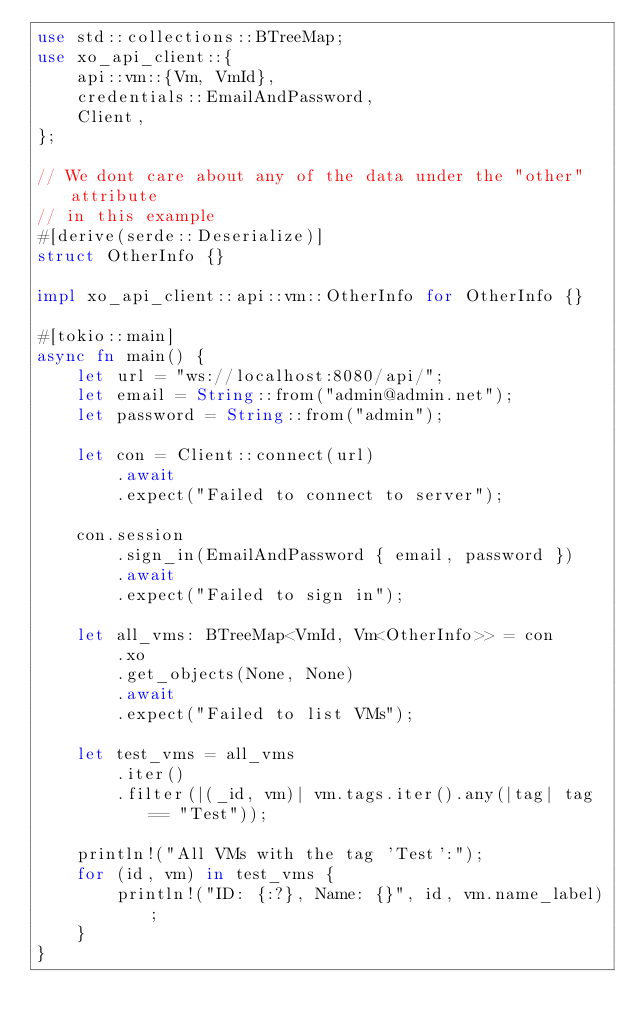<code> <loc_0><loc_0><loc_500><loc_500><_Rust_>use std::collections::BTreeMap;
use xo_api_client::{
    api::vm::{Vm, VmId},
    credentials::EmailAndPassword,
    Client,
};

// We dont care about any of the data under the "other" attribute
// in this example
#[derive(serde::Deserialize)]
struct OtherInfo {}

impl xo_api_client::api::vm::OtherInfo for OtherInfo {}

#[tokio::main]
async fn main() {
    let url = "ws://localhost:8080/api/";
    let email = String::from("admin@admin.net");
    let password = String::from("admin");

    let con = Client::connect(url)
        .await
        .expect("Failed to connect to server");

    con.session
        .sign_in(EmailAndPassword { email, password })
        .await
        .expect("Failed to sign in");

    let all_vms: BTreeMap<VmId, Vm<OtherInfo>> = con
        .xo
        .get_objects(None, None)
        .await
        .expect("Failed to list VMs");

    let test_vms = all_vms
        .iter()
        .filter(|(_id, vm)| vm.tags.iter().any(|tag| tag == "Test"));

    println!("All VMs with the tag 'Test':");
    for (id, vm) in test_vms {
        println!("ID: {:?}, Name: {}", id, vm.name_label);
    }
}
</code> 